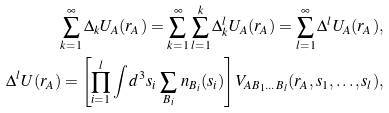Convert formula to latex. <formula><loc_0><loc_0><loc_500><loc_500>\sum _ { k = 1 } ^ { \infty } \Delta _ { k } U _ { A } ( r _ { A } ) = \sum _ { k = 1 } ^ { \infty } \sum _ { l = 1 } ^ { k } \Delta _ { k } ^ { l } U _ { A } ( r _ { A } ) = \sum _ { l = 1 } ^ { \infty } \Delta ^ { l } U _ { A } ( r _ { A } ) , \\ \Delta ^ { l } U ( r _ { A } ) = \left [ \prod _ { i = 1 } ^ { l } \int d ^ { 3 } s _ { i } \, \sum _ { B _ { i } } \, n _ { B _ { i } } ( s _ { i } ) \right ] V _ { A B _ { 1 } \dots B _ { l } } ( r _ { A } , s _ { 1 } , \dots , s _ { l } ) ,</formula> 